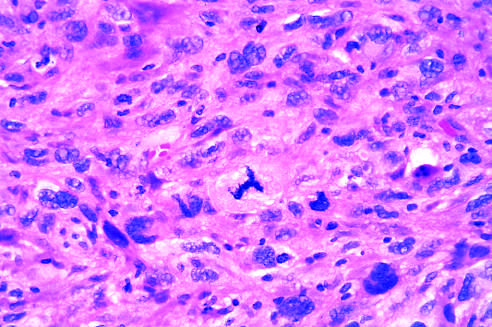does high-power detailed view of anaplastic tumor cells show cellular and nuclear variation in size and shape?
Answer the question using a single word or phrase. Yes 